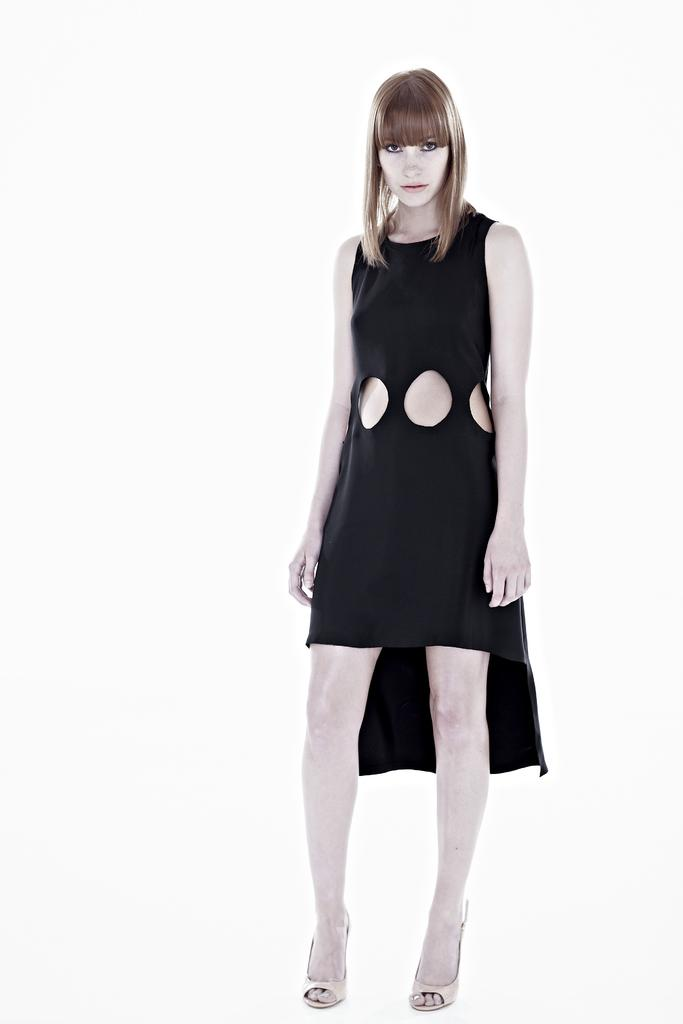What is the main subject of the image? There is a person standing in the image. What is the person wearing? The person is wearing a black dress. What color is the background of the image? The background of the image is white. Can you see a gate in the background of the image? There is no gate present in the image; the background is white. 